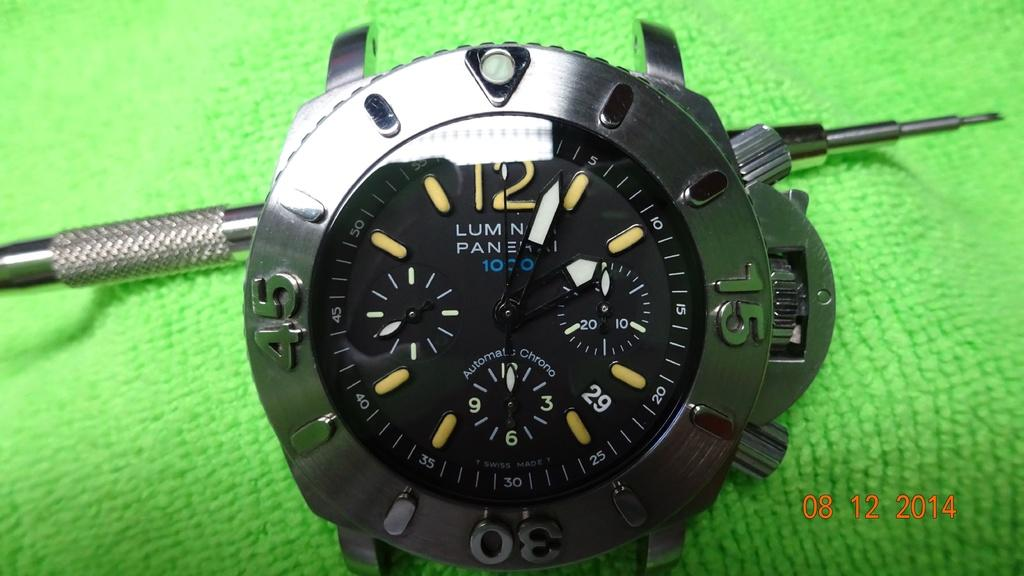Provide a one-sentence caption for the provided image. Luminar black, white, and blue watch on a green cloth. 